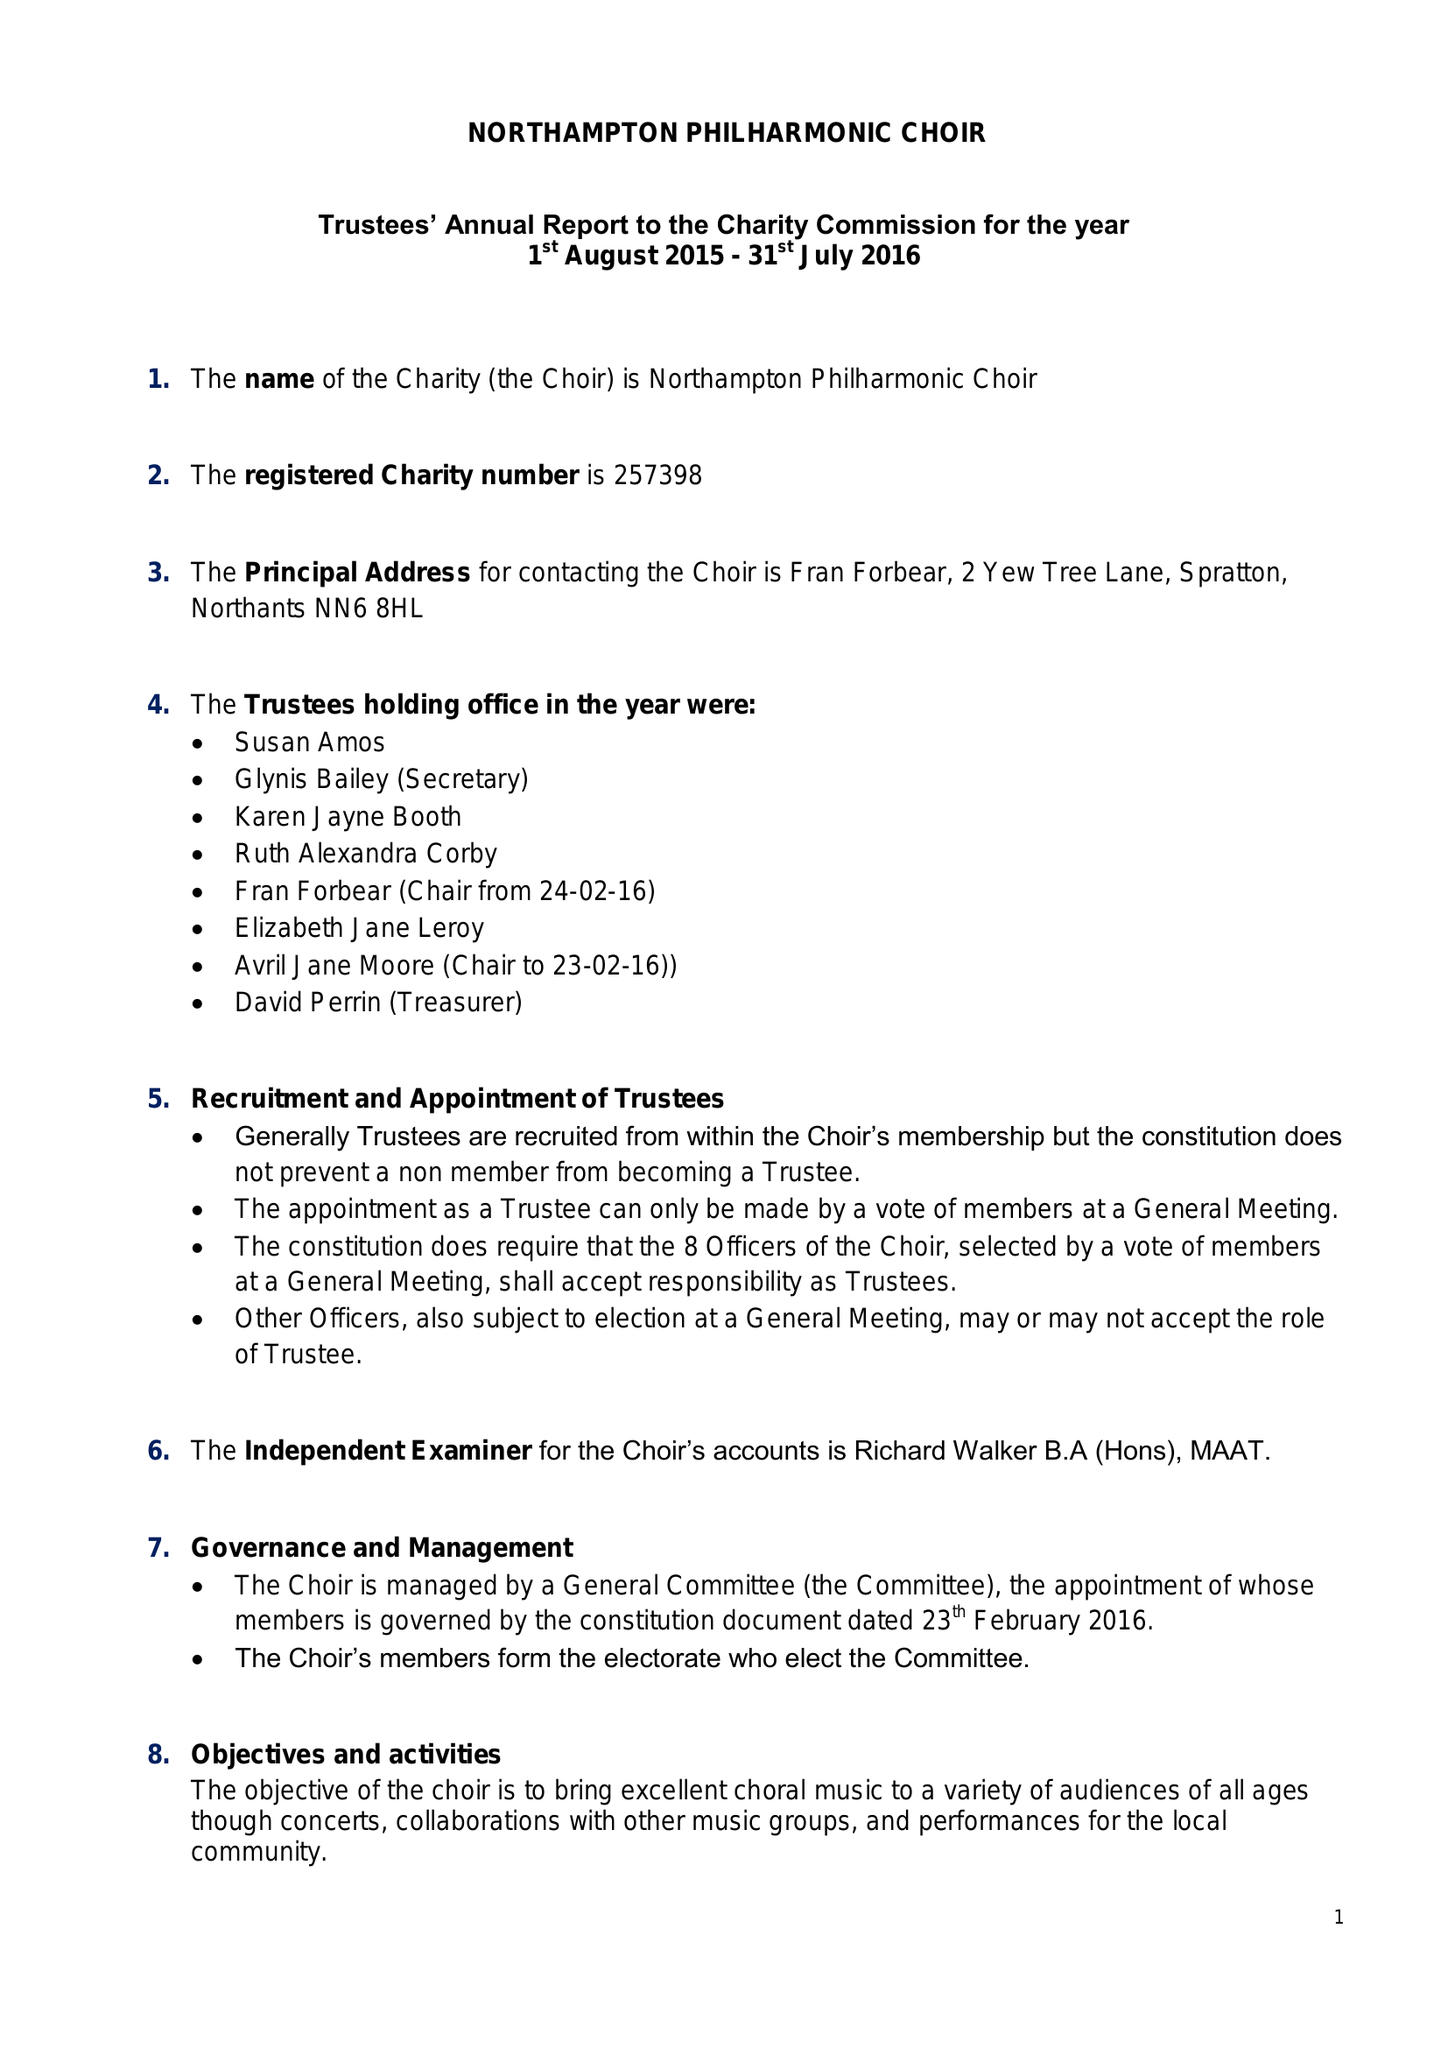What is the value for the charity_name?
Answer the question using a single word or phrase. Northampton Philharmonic Choir 